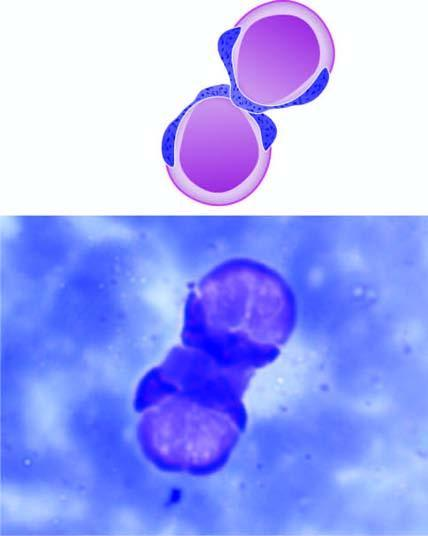what are two le cells there having?
Answer the question using a single word or phrase. Rounded masses of amorphous nuclear material (le body) 